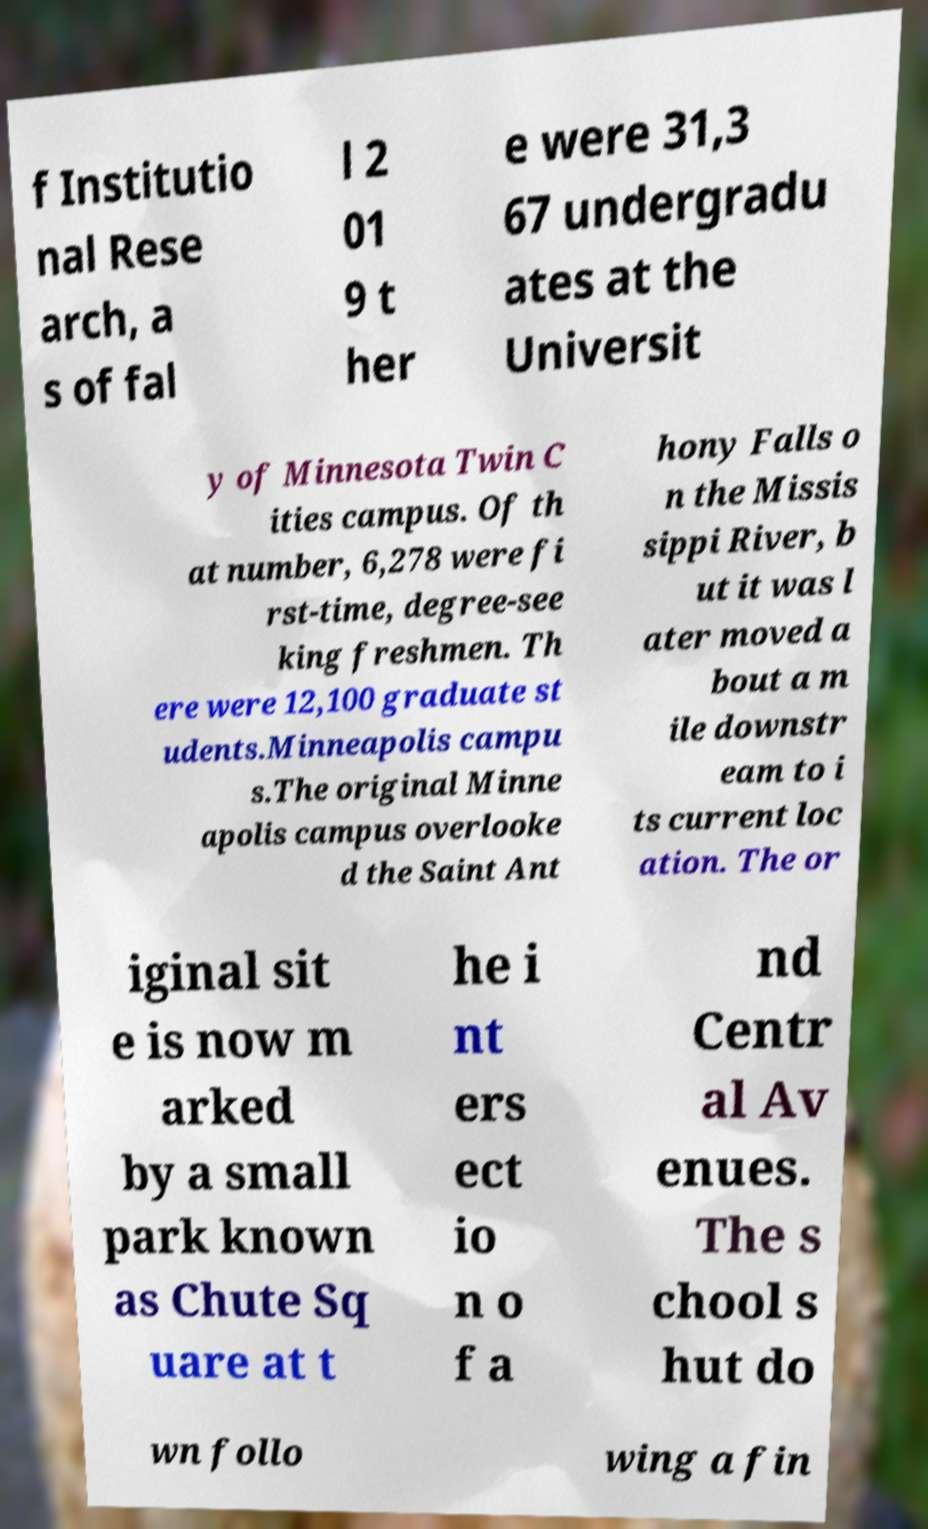Could you assist in decoding the text presented in this image and type it out clearly? f Institutio nal Rese arch, a s of fal l 2 01 9 t her e were 31,3 67 undergradu ates at the Universit y of Minnesota Twin C ities campus. Of th at number, 6,278 were fi rst-time, degree-see king freshmen. Th ere were 12,100 graduate st udents.Minneapolis campu s.The original Minne apolis campus overlooke d the Saint Ant hony Falls o n the Missis sippi River, b ut it was l ater moved a bout a m ile downstr eam to i ts current loc ation. The or iginal sit e is now m arked by a small park known as Chute Sq uare at t he i nt ers ect io n o f a nd Centr al Av enues. The s chool s hut do wn follo wing a fin 